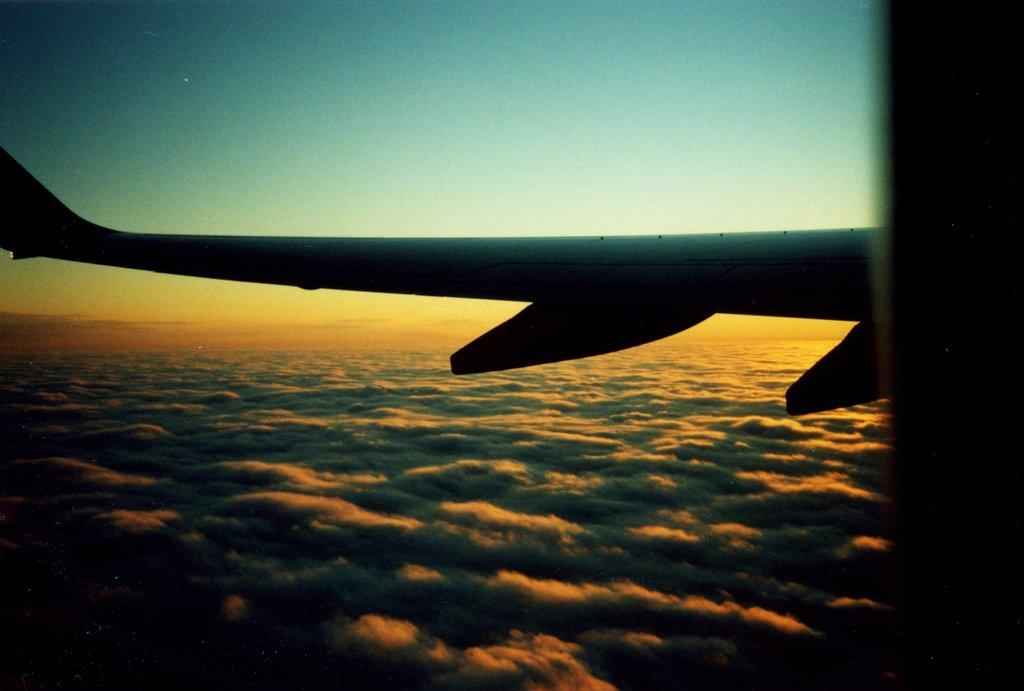What is the main subject of the image? The main subject of the image is a part of an aeroplane. What can be seen in the sky at the top of the image? The sky is visible at the top of the image. What direction is the aeroplane flying in the image? The image only shows a part of an aeroplane, and it is not possible to determine the direction it is flying in. What story is being told through the image? The image does not tell a story; it simply depicts a part of an aeroplane and the sky. What type of salt can be seen on the aeroplane in the image? There is no salt present in the image; it only features a part of an aeroplane and the sky. 